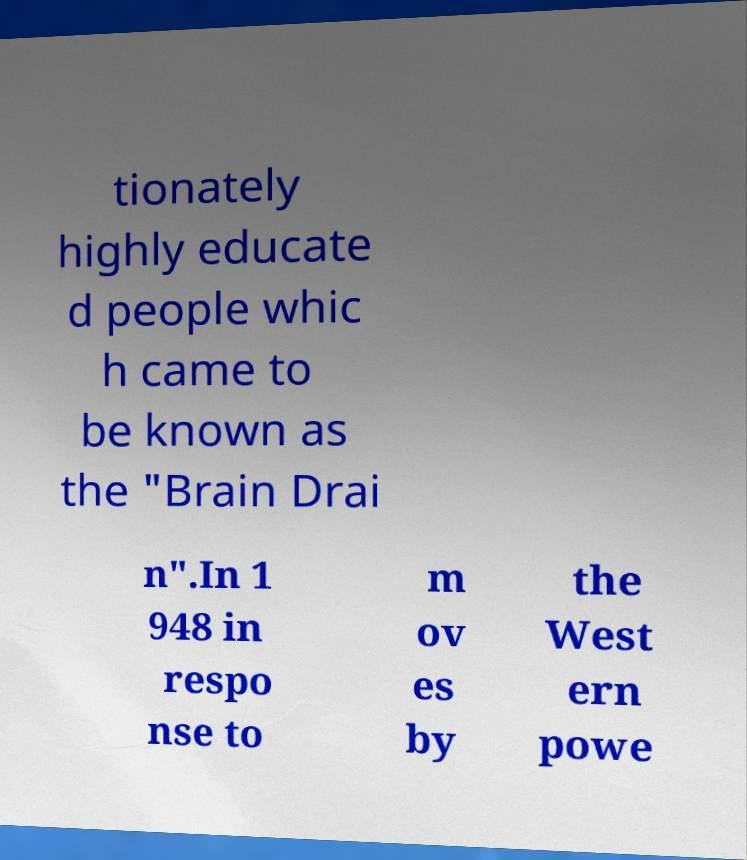Could you extract and type out the text from this image? tionately highly educate d people whic h came to be known as the "Brain Drai n".In 1 948 in respo nse to m ov es by the West ern powe 